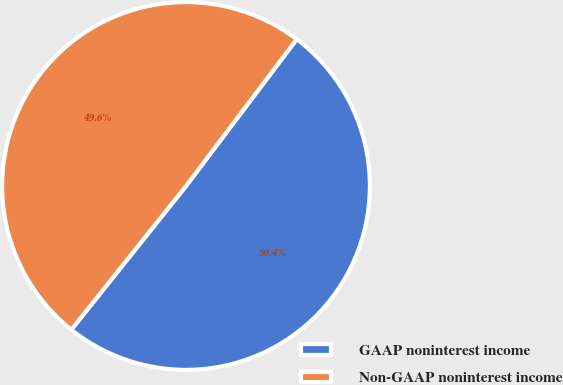Convert chart. <chart><loc_0><loc_0><loc_500><loc_500><pie_chart><fcel>GAAP noninterest income<fcel>Non-GAAP noninterest income<nl><fcel>50.44%<fcel>49.56%<nl></chart> 